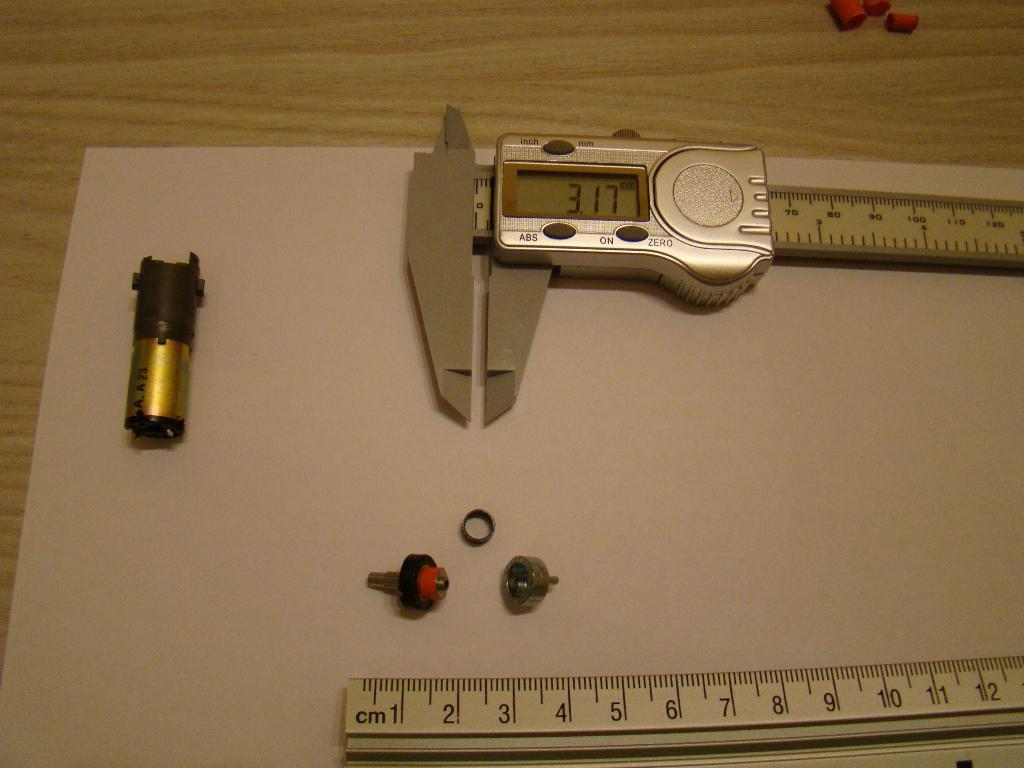<image>
Offer a succinct explanation of the picture presented. A table with a ruler on it and a device that reads 3.17 mm. 